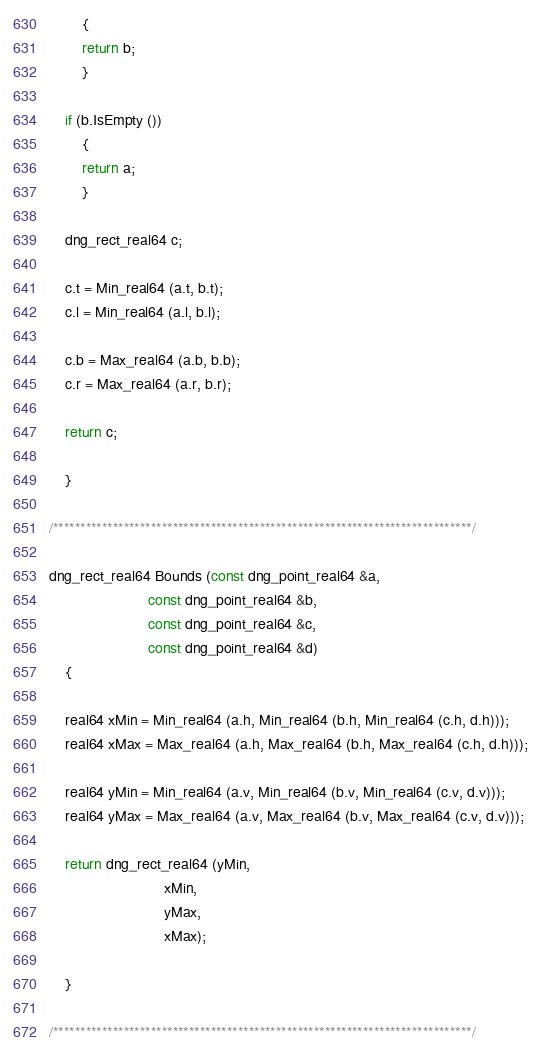<code> <loc_0><loc_0><loc_500><loc_500><_C++_>		{
		return b;
		}
		
	if (b.IsEmpty ())
		{
		return a;
		}
		
	dng_rect_real64 c;
	
	c.t = Min_real64 (a.t, b.t);
	c.l = Min_real64 (a.l, b.l);
	
	c.b = Max_real64 (a.b, b.b);
	c.r = Max_real64 (a.r, b.r);
	
	return c;
	
	}

/*****************************************************************************/

dng_rect_real64 Bounds (const dng_point_real64 &a,
						const dng_point_real64 &b,
						const dng_point_real64 &c,
						const dng_point_real64 &d)
	{
                                    
	real64 xMin = Min_real64 (a.h, Min_real64 (b.h, Min_real64 (c.h, d.h)));
	real64 xMax = Max_real64 (a.h, Max_real64 (b.h, Max_real64 (c.h, d.h)));

	real64 yMin = Min_real64 (a.v, Min_real64 (b.v, Min_real64 (c.v, d.v)));
	real64 yMax = Max_real64 (a.v, Max_real64 (b.v, Max_real64 (c.v, d.v)));

	return dng_rect_real64 (yMin,
							xMin,
							yMax,
							xMax);
                                    
	}

/*****************************************************************************/
</code> 